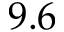Convert formula to latex. <formula><loc_0><loc_0><loc_500><loc_500>9 . 6</formula> 